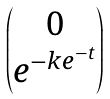<formula> <loc_0><loc_0><loc_500><loc_500>\begin{pmatrix} 0 \\ e ^ { - k e ^ { - t } } \\ \end{pmatrix}</formula> 